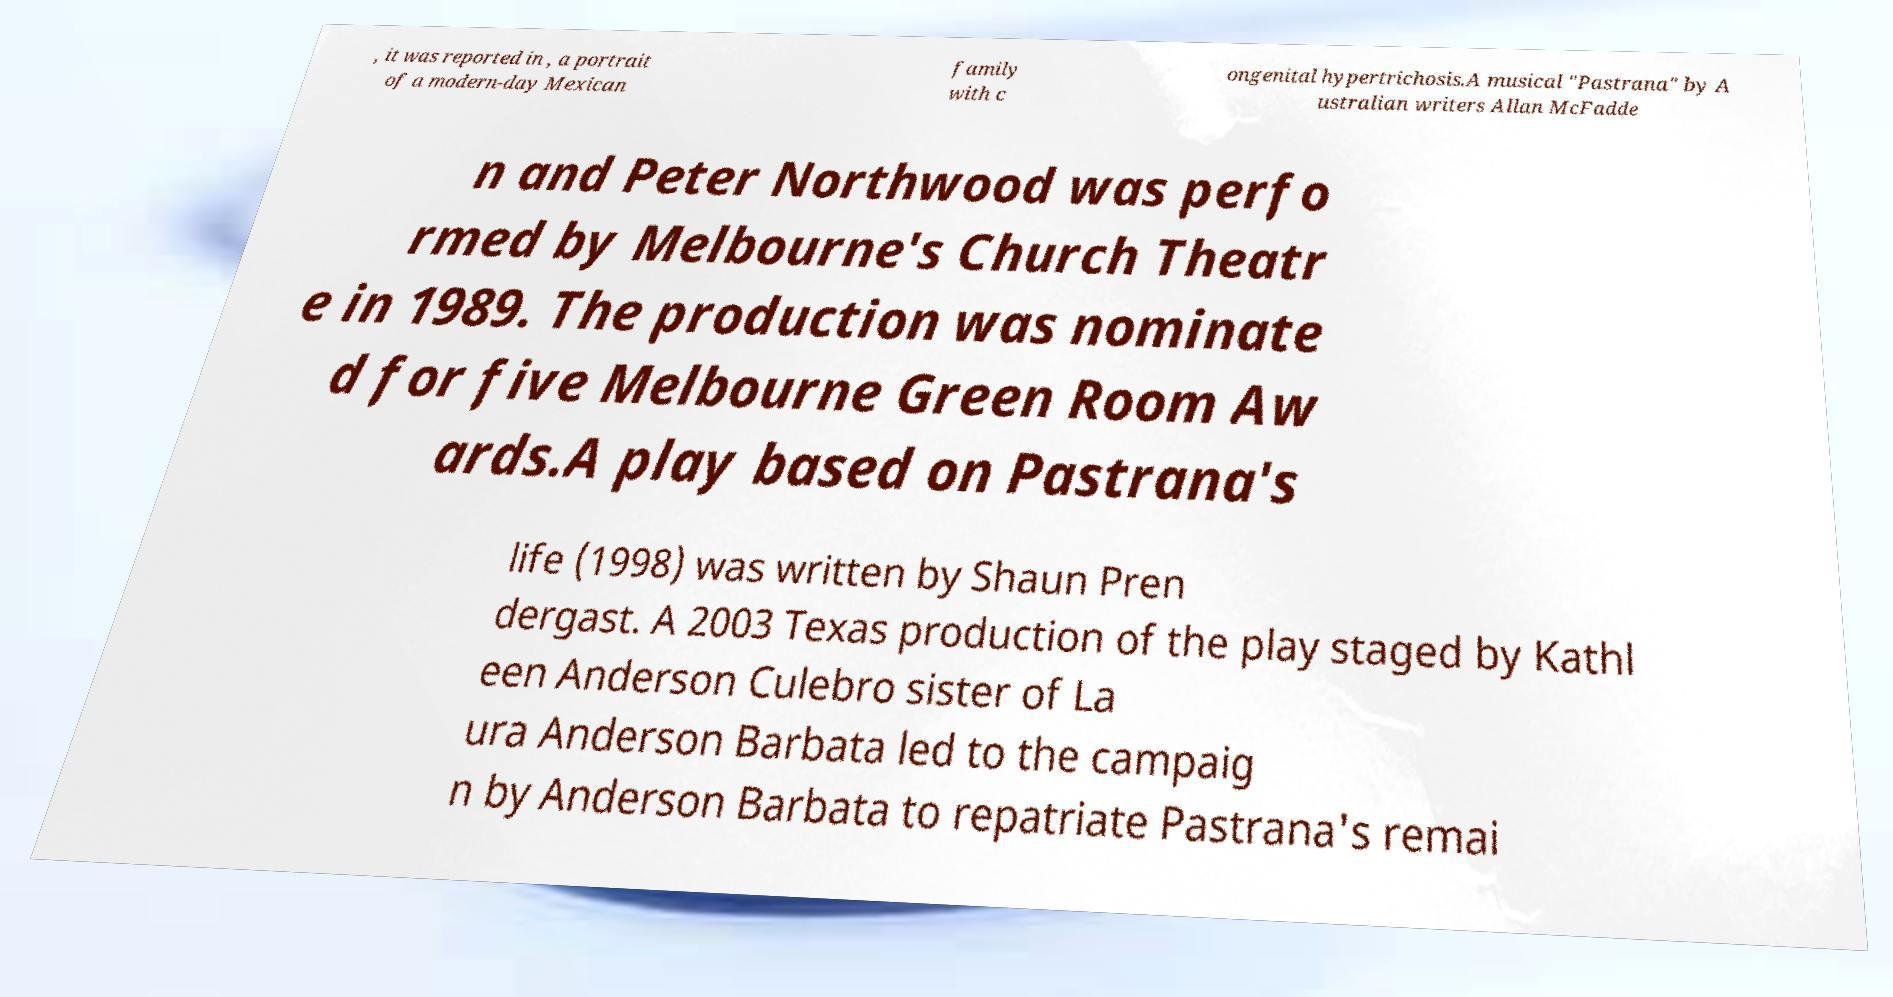Could you extract and type out the text from this image? , it was reported in , a portrait of a modern-day Mexican family with c ongenital hypertrichosis.A musical "Pastrana" by A ustralian writers Allan McFadde n and Peter Northwood was perfo rmed by Melbourne's Church Theatr e in 1989. The production was nominate d for five Melbourne Green Room Aw ards.A play based on Pastrana's life (1998) was written by Shaun Pren dergast. A 2003 Texas production of the play staged by Kathl een Anderson Culebro sister of La ura Anderson Barbata led to the campaig n by Anderson Barbata to repatriate Pastrana's remai 